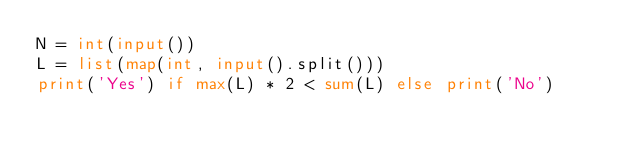<code> <loc_0><loc_0><loc_500><loc_500><_Python_>N = int(input())
L = list(map(int, input().split()))
print('Yes') if max(L) * 2 < sum(L) else print('No')</code> 